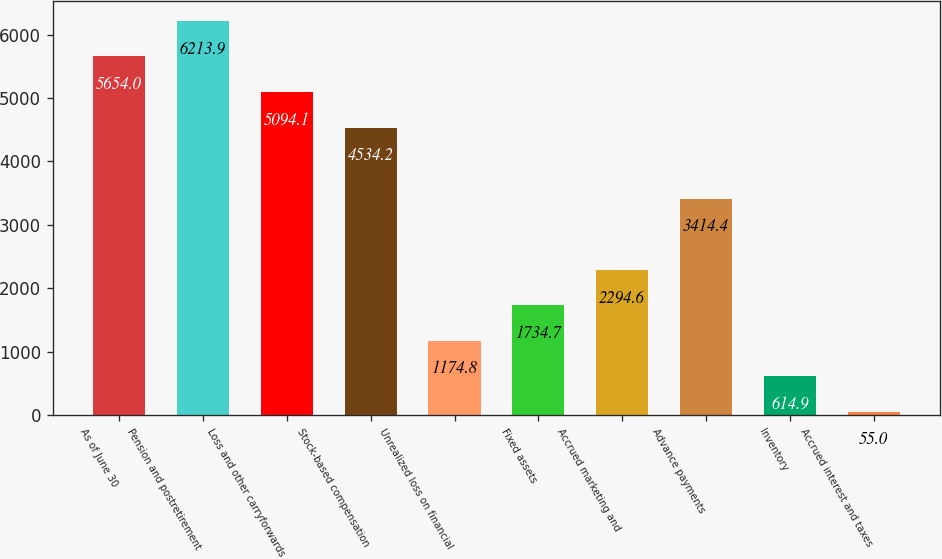Convert chart. <chart><loc_0><loc_0><loc_500><loc_500><bar_chart><fcel>As of June 30<fcel>Pension and postretirement<fcel>Loss and other carryforwards<fcel>Stock-based compensation<fcel>Unrealized loss on financial<fcel>Fixed assets<fcel>Accrued marketing and<fcel>Advance payments<fcel>Inventory<fcel>Accrued interest and taxes<nl><fcel>5654<fcel>6213.9<fcel>5094.1<fcel>4534.2<fcel>1174.8<fcel>1734.7<fcel>2294.6<fcel>3414.4<fcel>614.9<fcel>55<nl></chart> 